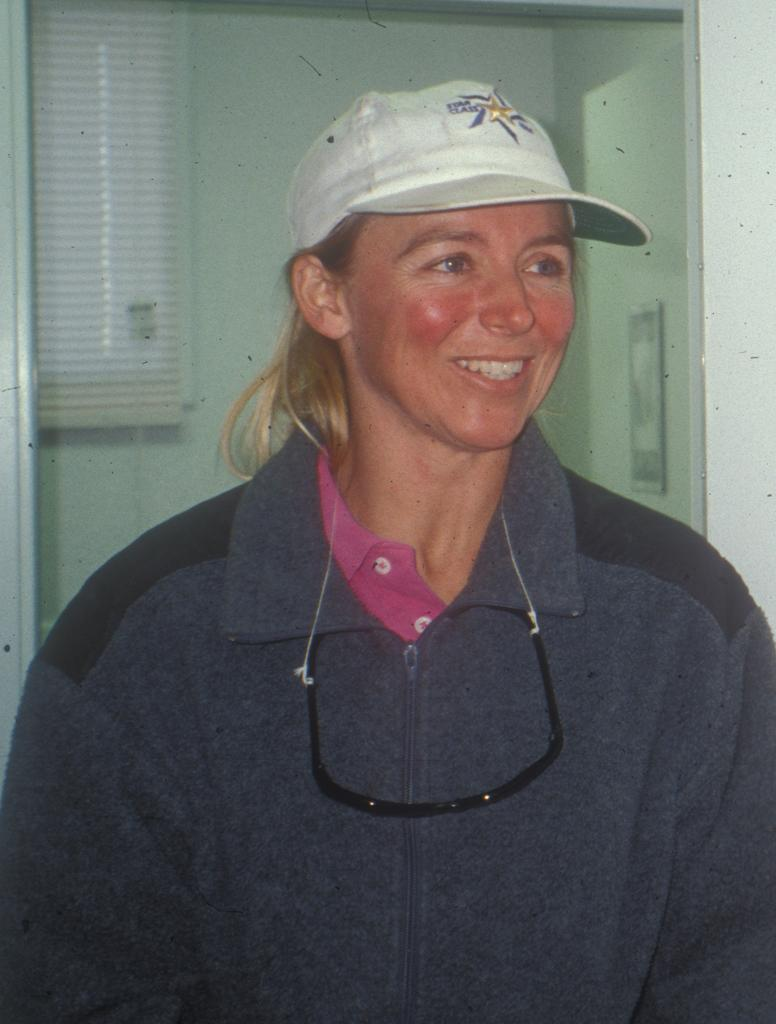Who is the main subject in the image? There is a lady in the image. Where is the lady positioned in the image? The lady is in the center of the image. What type of headwear is the lady wearing? The lady is wearing a cap. What type of fairies can be seen flying around the lady in the image? There are no fairies present in the image; it only features a lady wearing a cap. What type of sport is the lady playing in the image? There is no sport, such as volleyball, being played in the image. 